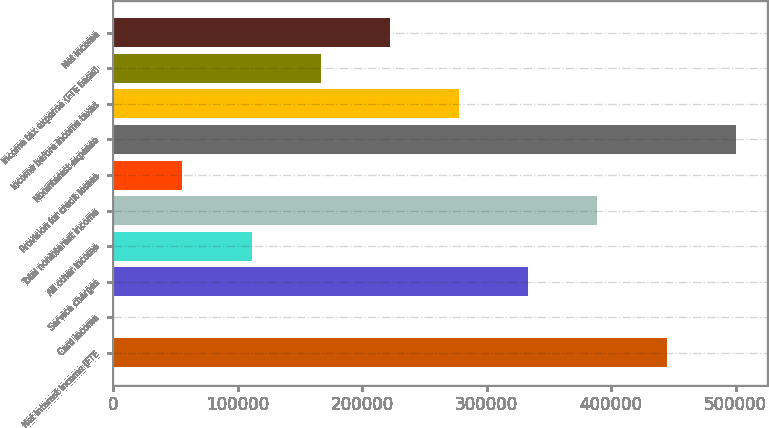Convert chart to OTSL. <chart><loc_0><loc_0><loc_500><loc_500><bar_chart><fcel>Net interest income (FTE<fcel>Card income<fcel>Service charges<fcel>All other income<fcel>Total noninterest income<fcel>Provision for credit losses<fcel>Noninterest expense<fcel>Income before income taxes<fcel>Income tax expense (FTE basis)<fcel>Net income<nl><fcel>444562<fcel>60<fcel>333436<fcel>111185<fcel>388999<fcel>55622.7<fcel>500124<fcel>277874<fcel>166748<fcel>222311<nl></chart> 